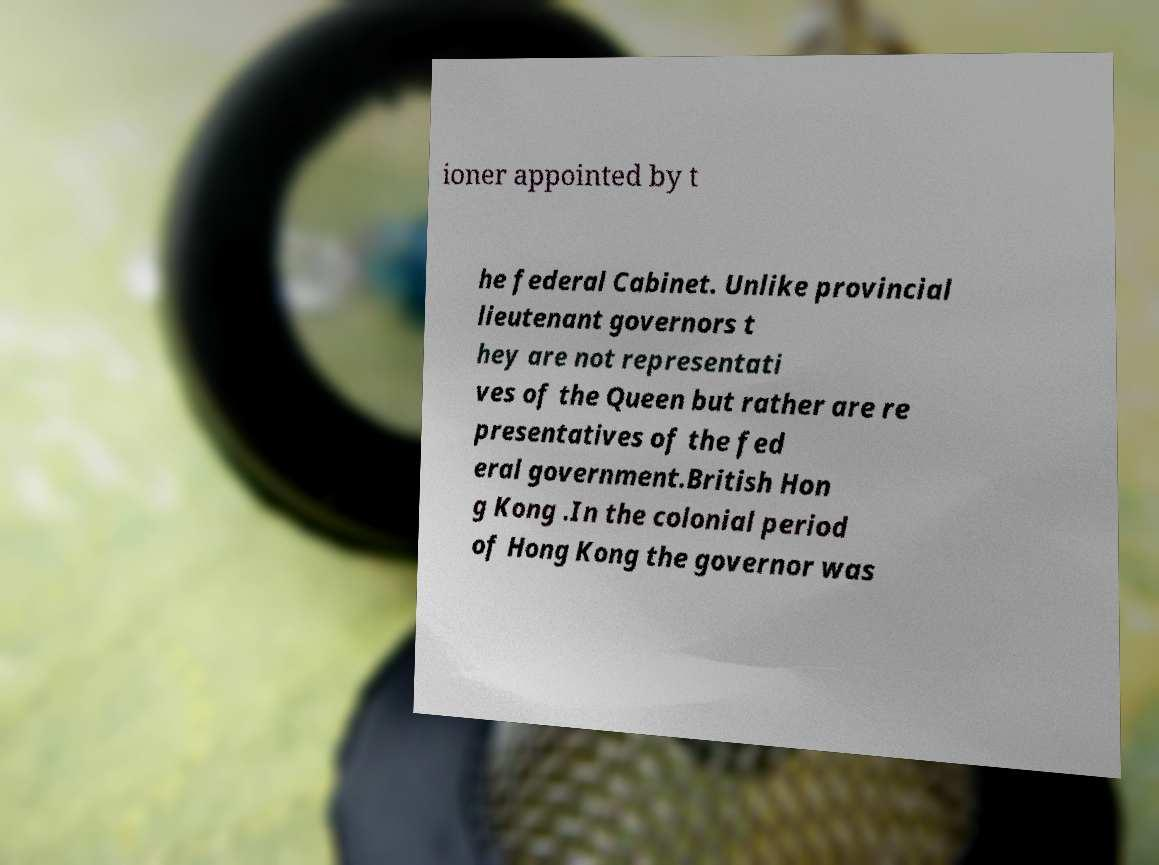Could you extract and type out the text from this image? ioner appointed by t he federal Cabinet. Unlike provincial lieutenant governors t hey are not representati ves of the Queen but rather are re presentatives of the fed eral government.British Hon g Kong .In the colonial period of Hong Kong the governor was 